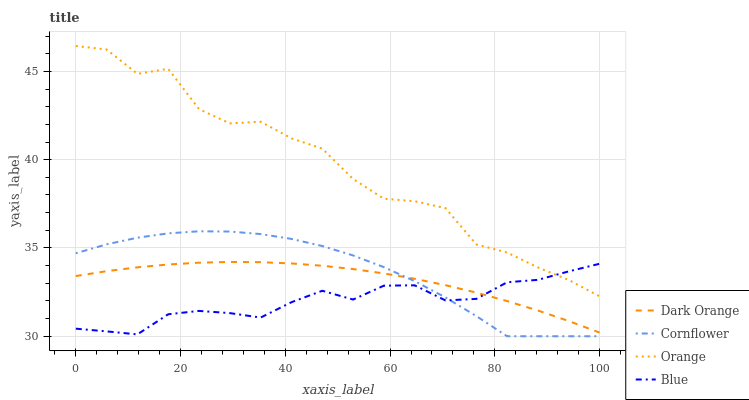Does Dark Orange have the minimum area under the curve?
Answer yes or no. No. Does Dark Orange have the maximum area under the curve?
Answer yes or no. No. Is Blue the smoothest?
Answer yes or no. No. Is Blue the roughest?
Answer yes or no. No. Does Dark Orange have the lowest value?
Answer yes or no. No. Does Dark Orange have the highest value?
Answer yes or no. No. Is Dark Orange less than Orange?
Answer yes or no. Yes. Is Orange greater than Dark Orange?
Answer yes or no. Yes. Does Dark Orange intersect Orange?
Answer yes or no. No. 